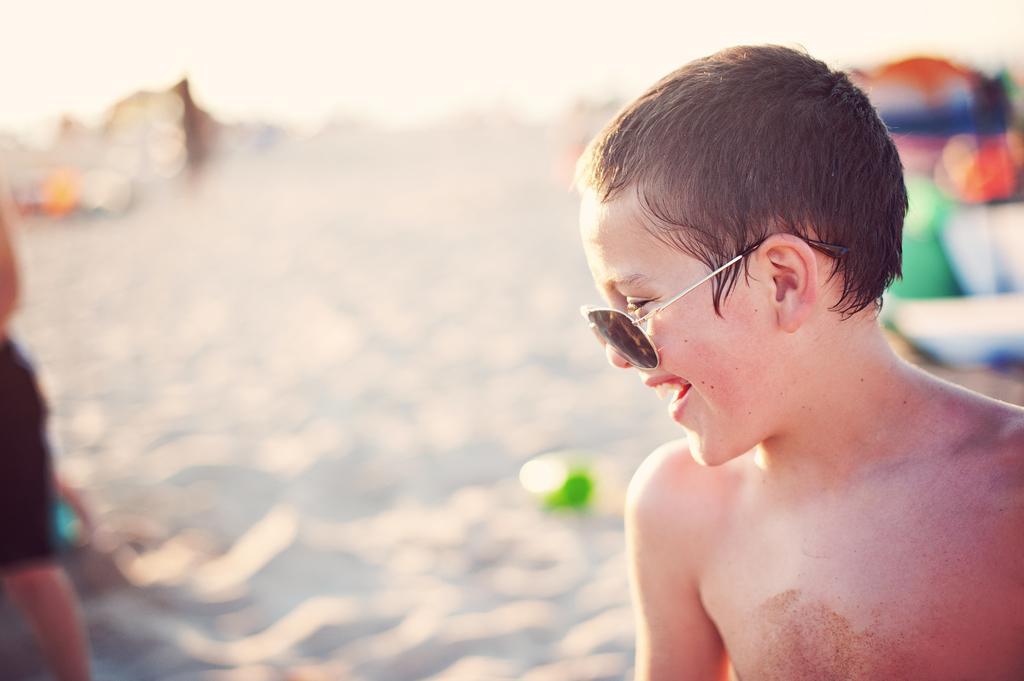Describe this image in one or two sentences. Here in this picture we can see a child present over a place and we can see he is smiling and wearing goggles on him and we can see sand present on the ground, which is totally in blurry manner. 